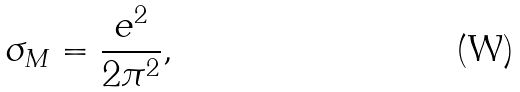Convert formula to latex. <formula><loc_0><loc_0><loc_500><loc_500>\sigma _ { M } = \frac { e ^ { 2 } } { 2 \pi ^ { 2 } } ,</formula> 